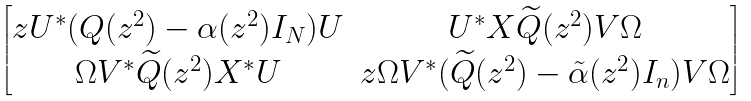<formula> <loc_0><loc_0><loc_500><loc_500>\begin{bmatrix} { z } U ^ { * } ( Q ( z ^ { 2 } ) - \alpha ( z ^ { 2 } ) I _ { N } ) U & U ^ { * } X \widetilde { Q } ( z ^ { 2 } ) V \Omega \\ \Omega V ^ { * } \widetilde { Q } ( z ^ { 2 } ) X ^ { * } U & { z } \Omega V ^ { * } ( \widetilde { Q } ( z ^ { 2 } ) - \tilde { \alpha } ( z ^ { 2 } ) I _ { n } ) V \Omega \end{bmatrix}</formula> 